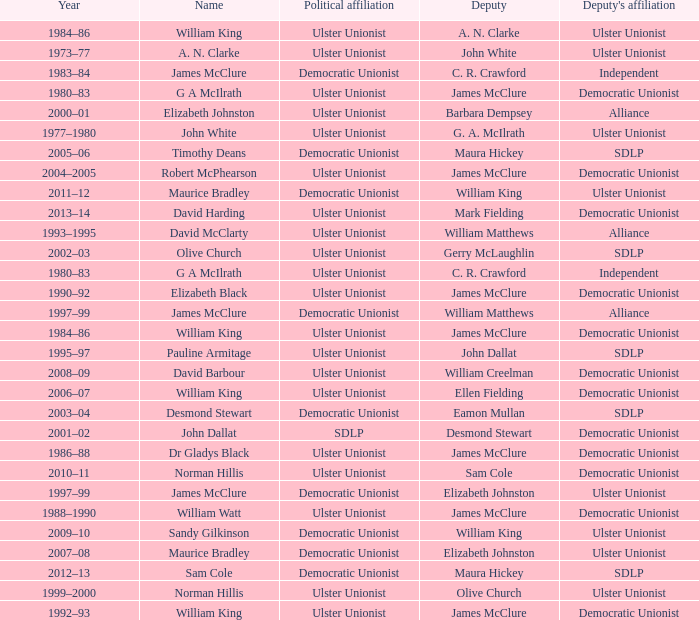What Year was james mcclure Deputy, and the Name is robert mcphearson? 2004–2005. 